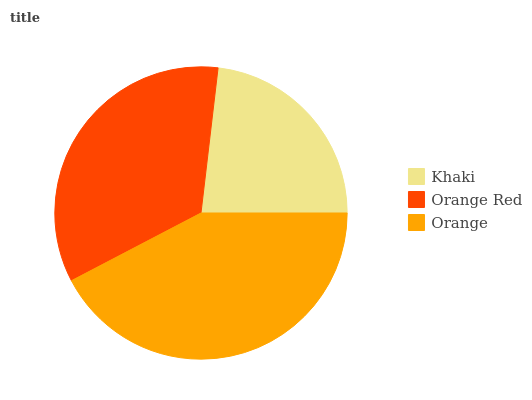Is Khaki the minimum?
Answer yes or no. Yes. Is Orange the maximum?
Answer yes or no. Yes. Is Orange Red the minimum?
Answer yes or no. No. Is Orange Red the maximum?
Answer yes or no. No. Is Orange Red greater than Khaki?
Answer yes or no. Yes. Is Khaki less than Orange Red?
Answer yes or no. Yes. Is Khaki greater than Orange Red?
Answer yes or no. No. Is Orange Red less than Khaki?
Answer yes or no. No. Is Orange Red the high median?
Answer yes or no. Yes. Is Orange Red the low median?
Answer yes or no. Yes. Is Khaki the high median?
Answer yes or no. No. Is Khaki the low median?
Answer yes or no. No. 